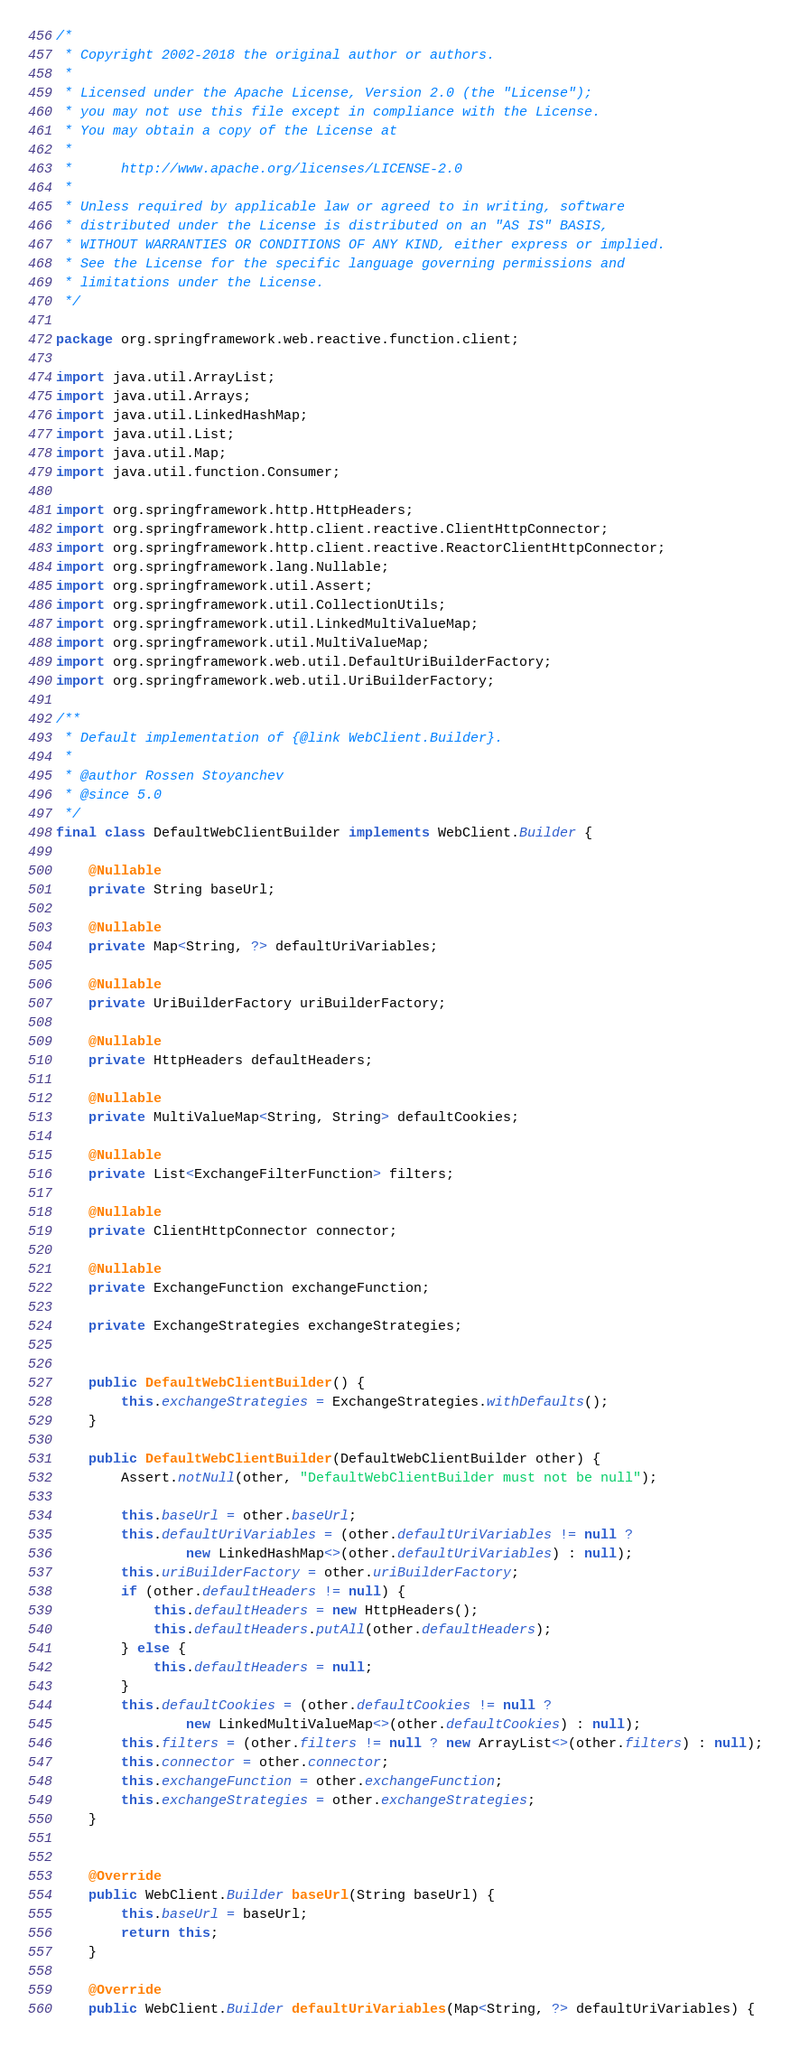Convert code to text. <code><loc_0><loc_0><loc_500><loc_500><_Java_>/*
 * Copyright 2002-2018 the original author or authors.
 *
 * Licensed under the Apache License, Version 2.0 (the "License");
 * you may not use this file except in compliance with the License.
 * You may obtain a copy of the License at
 *
 *      http://www.apache.org/licenses/LICENSE-2.0
 *
 * Unless required by applicable law or agreed to in writing, software
 * distributed under the License is distributed on an "AS IS" BASIS,
 * WITHOUT WARRANTIES OR CONDITIONS OF ANY KIND, either express or implied.
 * See the License for the specific language governing permissions and
 * limitations under the License.
 */

package org.springframework.web.reactive.function.client;

import java.util.ArrayList;
import java.util.Arrays;
import java.util.LinkedHashMap;
import java.util.List;
import java.util.Map;
import java.util.function.Consumer;

import org.springframework.http.HttpHeaders;
import org.springframework.http.client.reactive.ClientHttpConnector;
import org.springframework.http.client.reactive.ReactorClientHttpConnector;
import org.springframework.lang.Nullable;
import org.springframework.util.Assert;
import org.springframework.util.CollectionUtils;
import org.springframework.util.LinkedMultiValueMap;
import org.springframework.util.MultiValueMap;
import org.springframework.web.util.DefaultUriBuilderFactory;
import org.springframework.web.util.UriBuilderFactory;

/**
 * Default implementation of {@link WebClient.Builder}.
 *
 * @author Rossen Stoyanchev
 * @since 5.0
 */
final class DefaultWebClientBuilder implements WebClient.Builder {

	@Nullable
	private String baseUrl;

	@Nullable
	private Map<String, ?> defaultUriVariables;

	@Nullable
	private UriBuilderFactory uriBuilderFactory;

	@Nullable
	private HttpHeaders defaultHeaders;

	@Nullable
	private MultiValueMap<String, String> defaultCookies;

	@Nullable
	private List<ExchangeFilterFunction> filters;

	@Nullable
	private ClientHttpConnector connector;

	@Nullable
	private ExchangeFunction exchangeFunction;

	private ExchangeStrategies exchangeStrategies;


	public DefaultWebClientBuilder() {
		this.exchangeStrategies = ExchangeStrategies.withDefaults();
	}

	public DefaultWebClientBuilder(DefaultWebClientBuilder other) {
		Assert.notNull(other, "DefaultWebClientBuilder must not be null");

		this.baseUrl = other.baseUrl;
		this.defaultUriVariables = (other.defaultUriVariables != null ?
				new LinkedHashMap<>(other.defaultUriVariables) : null);
		this.uriBuilderFactory = other.uriBuilderFactory;
		if (other.defaultHeaders != null) {
			this.defaultHeaders = new HttpHeaders();
			this.defaultHeaders.putAll(other.defaultHeaders);
		} else {
			this.defaultHeaders = null;
		}
		this.defaultCookies = (other.defaultCookies != null ?
				new LinkedMultiValueMap<>(other.defaultCookies) : null);
		this.filters = (other.filters != null ? new ArrayList<>(other.filters) : null);
		this.connector = other.connector;
		this.exchangeFunction = other.exchangeFunction;
		this.exchangeStrategies = other.exchangeStrategies;
	}


	@Override
	public WebClient.Builder baseUrl(String baseUrl) {
		this.baseUrl = baseUrl;
		return this;
	}

	@Override
	public WebClient.Builder defaultUriVariables(Map<String, ?> defaultUriVariables) {</code> 